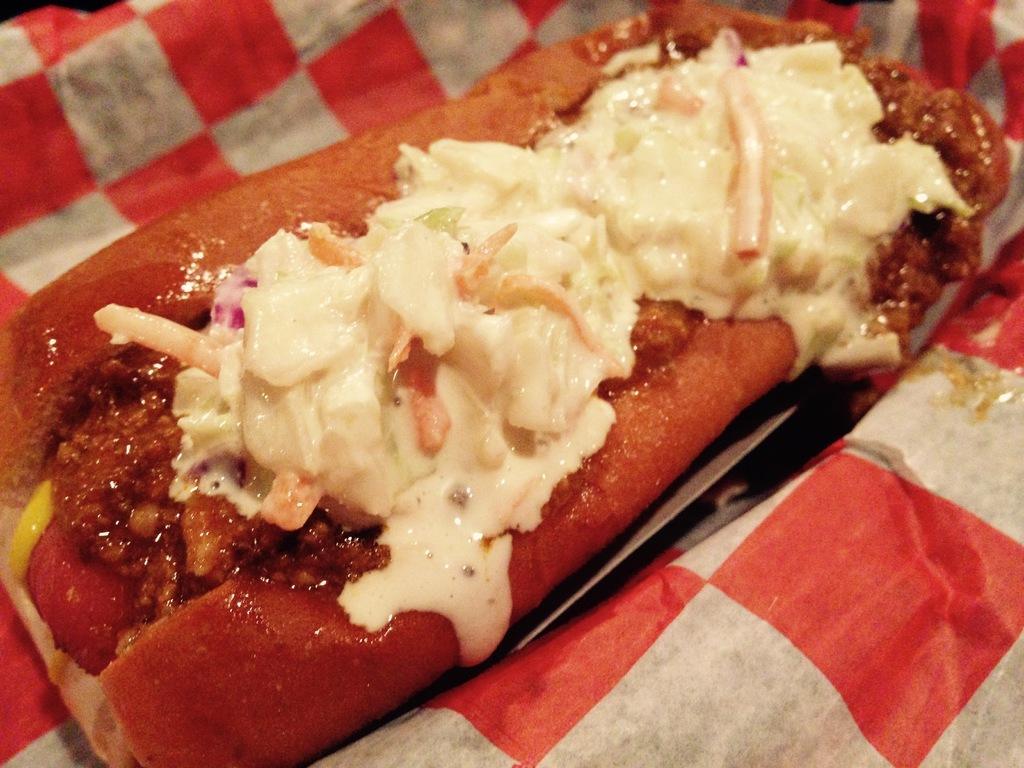Could you give a brief overview of what you see in this image? Here in this picture we can see a food item present on a plate, which is present on a place over there. 